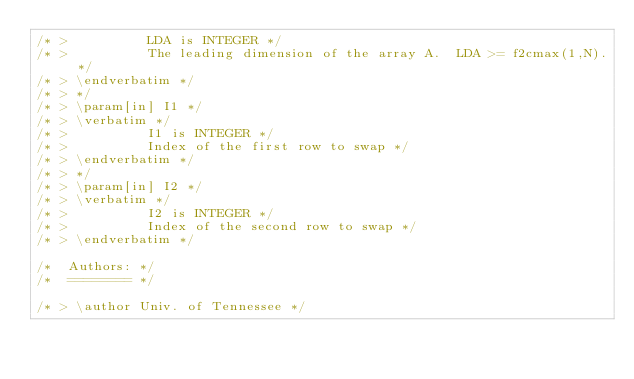<code> <loc_0><loc_0><loc_500><loc_500><_C_>/* >          LDA is INTEGER */
/* >          The leading dimension of the array A.  LDA >= f2cmax(1,N). */
/* > \endverbatim */
/* > */
/* > \param[in] I1 */
/* > \verbatim */
/* >          I1 is INTEGER */
/* >          Index of the first row to swap */
/* > \endverbatim */
/* > */
/* > \param[in] I2 */
/* > \verbatim */
/* >          I2 is INTEGER */
/* >          Index of the second row to swap */
/* > \endverbatim */

/*  Authors: */
/*  ======== */

/* > \author Univ. of Tennessee */</code> 